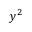Convert formula to latex. <formula><loc_0><loc_0><loc_500><loc_500>y ^ { 2 }</formula> 